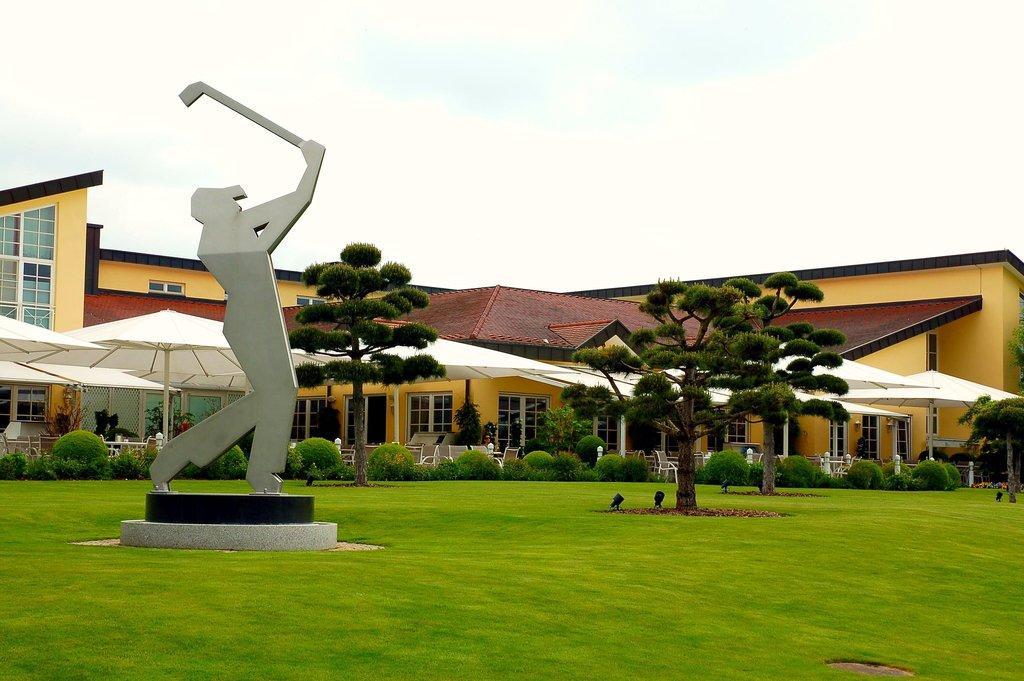Please provide a concise description of this image. This picture shows stories and we see umbrellas and a building and we see a statue and grass on the ground and a cloudy sky. 